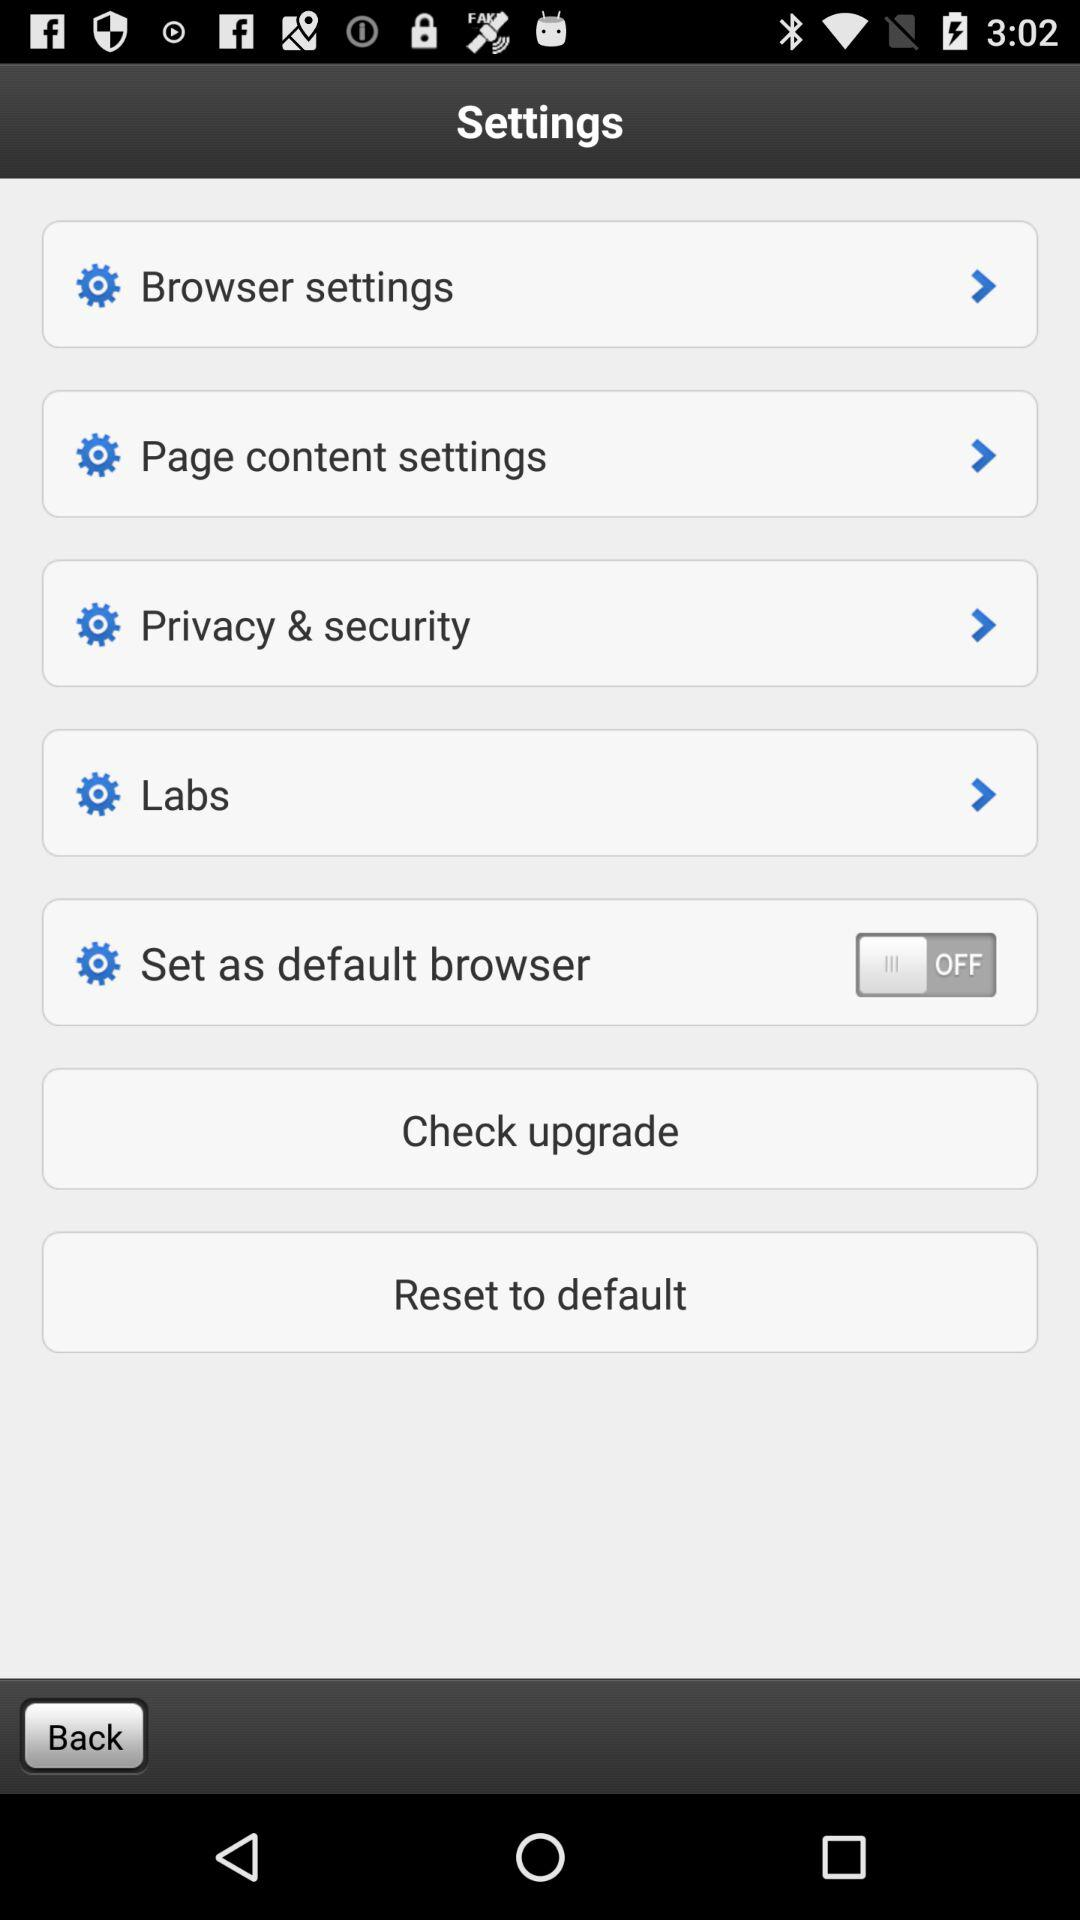How many of the settings have a switch?
Answer the question using a single word or phrase. 1 